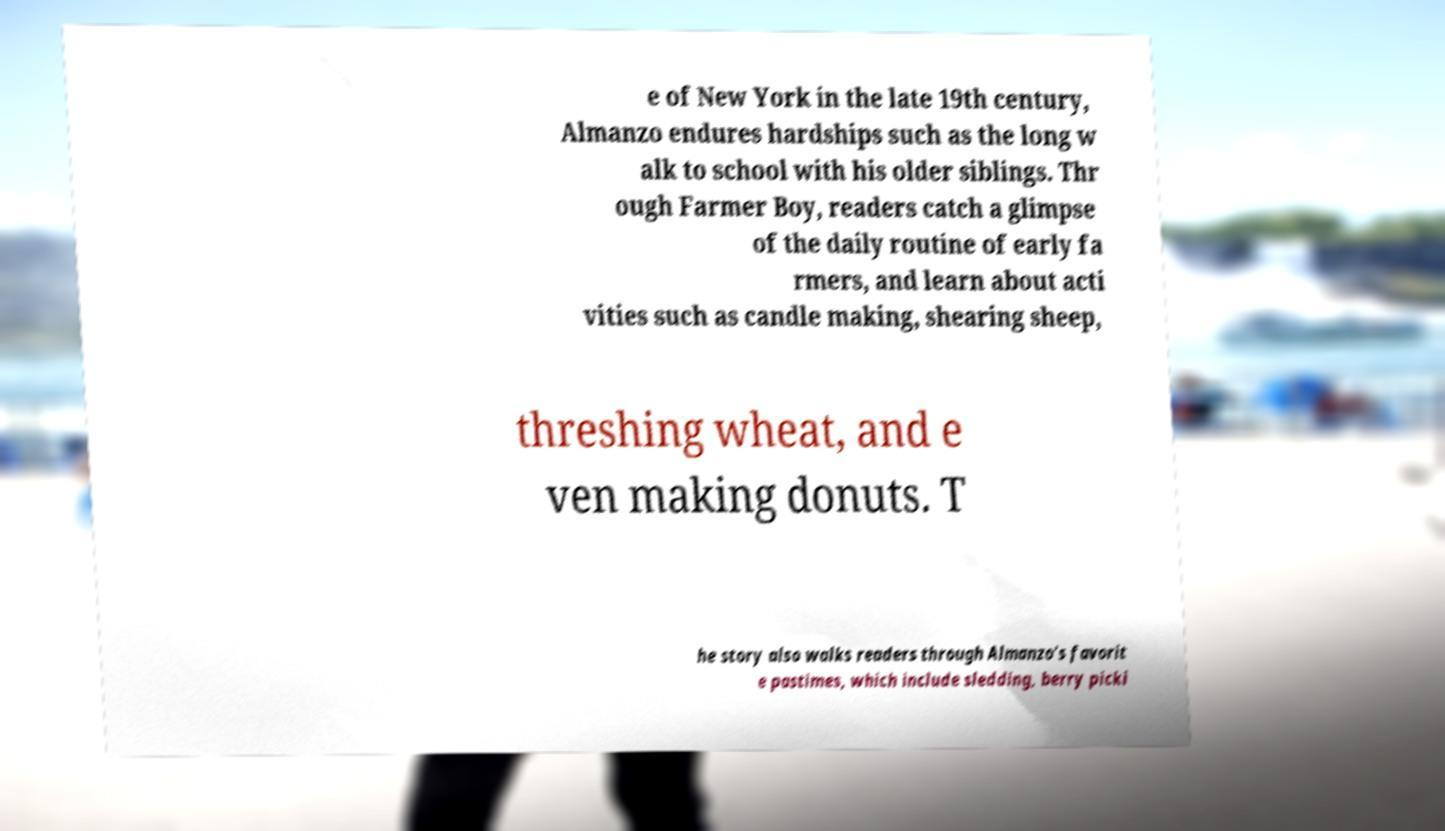Could you extract and type out the text from this image? e of New York in the late 19th century, Almanzo endures hardships such as the long w alk to school with his older siblings. Thr ough Farmer Boy, readers catch a glimpse of the daily routine of early fa rmers, and learn about acti vities such as candle making, shearing sheep, threshing wheat, and e ven making donuts. T he story also walks readers through Almanzo’s favorit e pastimes, which include sledding, berry picki 